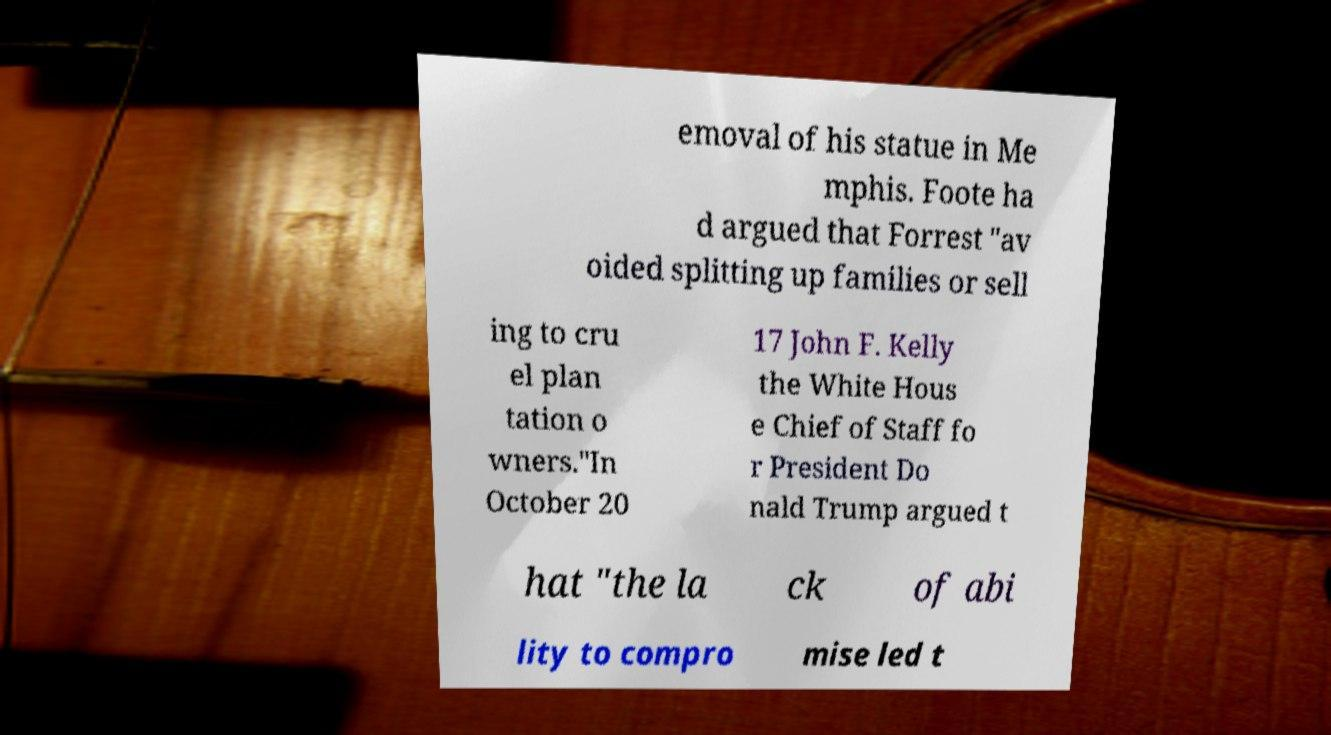There's text embedded in this image that I need extracted. Can you transcribe it verbatim? emoval of his statue in Me mphis. Foote ha d argued that Forrest "av oided splitting up families or sell ing to cru el plan tation o wners."In October 20 17 John F. Kelly the White Hous e Chief of Staff fo r President Do nald Trump argued t hat "the la ck of abi lity to compro mise led t 